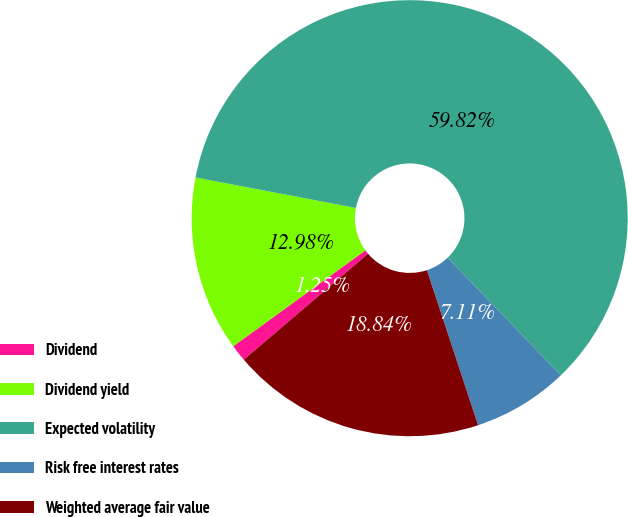Convert chart. <chart><loc_0><loc_0><loc_500><loc_500><pie_chart><fcel>Dividend<fcel>Dividend yield<fcel>Expected volatility<fcel>Risk free interest rates<fcel>Weighted average fair value<nl><fcel>1.25%<fcel>12.98%<fcel>59.82%<fcel>7.11%<fcel>18.84%<nl></chart> 